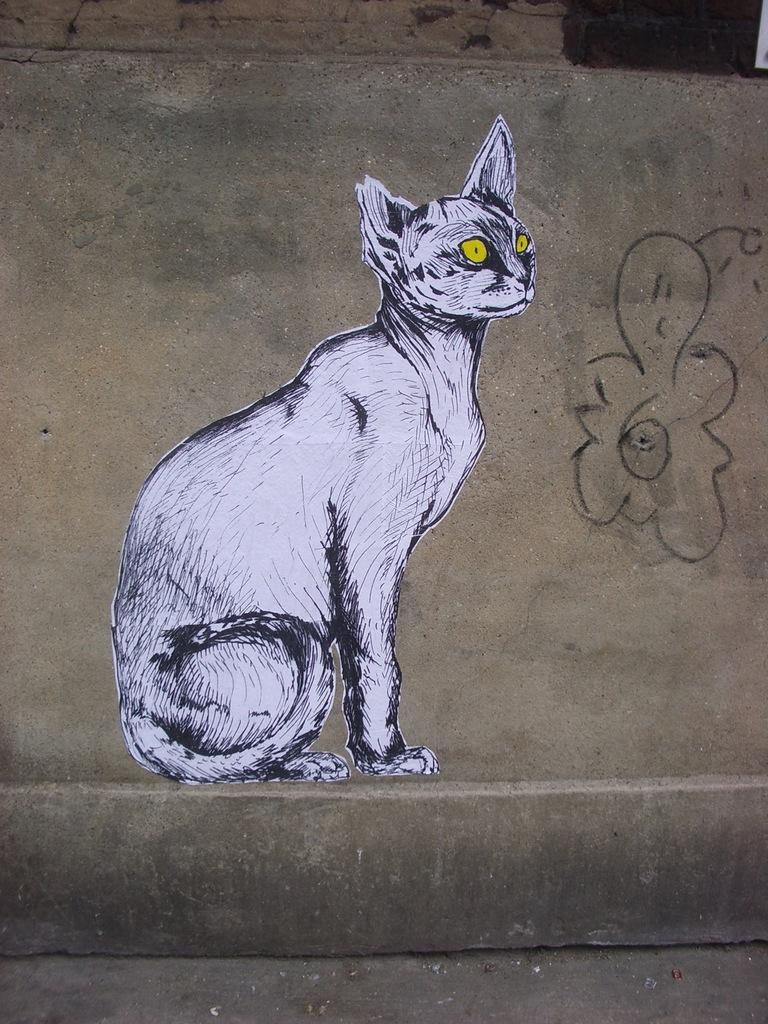What can be seen on the wall in the image? There is a painting of a cat on the wall in the image. What type of artwork is depicted on the wall? The artwork is a painting of a cat. Where can the receipt for the underwear be found in the image? There is no receipt or underwear present in the image; it only features a wall with a painting of a cat. 